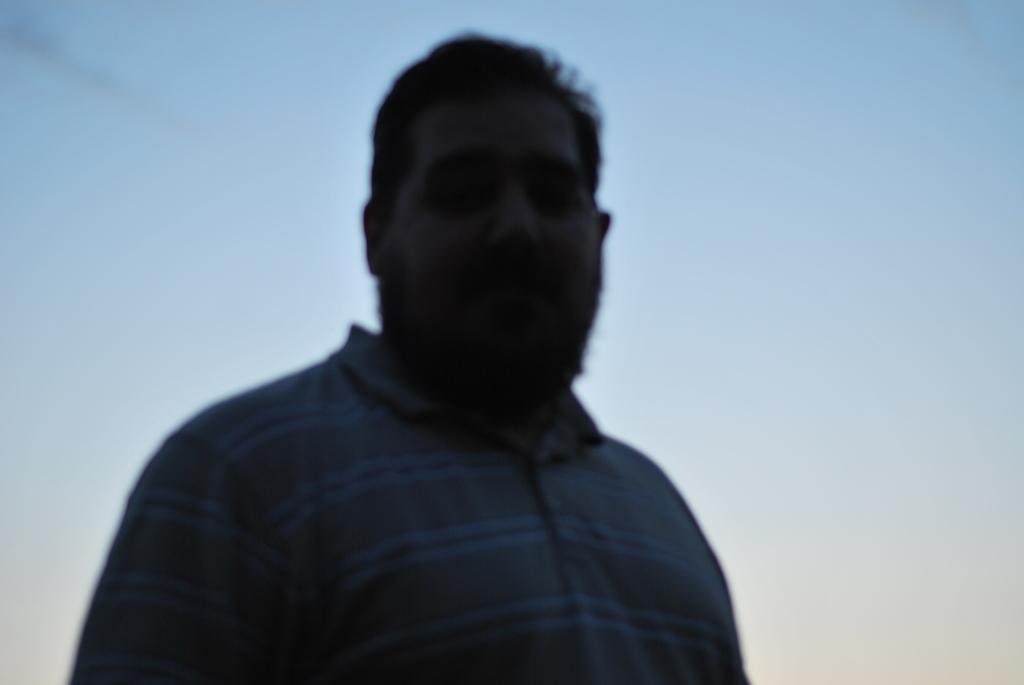Who is present in the image? There is a man in the image. What is the man wearing in the image? The man is wearing a t-shirt in the image. How would you describe the sky in the image? The sky is blue and cloudy in the image. What type of foot is the man using to drive in the image? There is no driving activity depicted in the image, and the man's feet are not visible. 